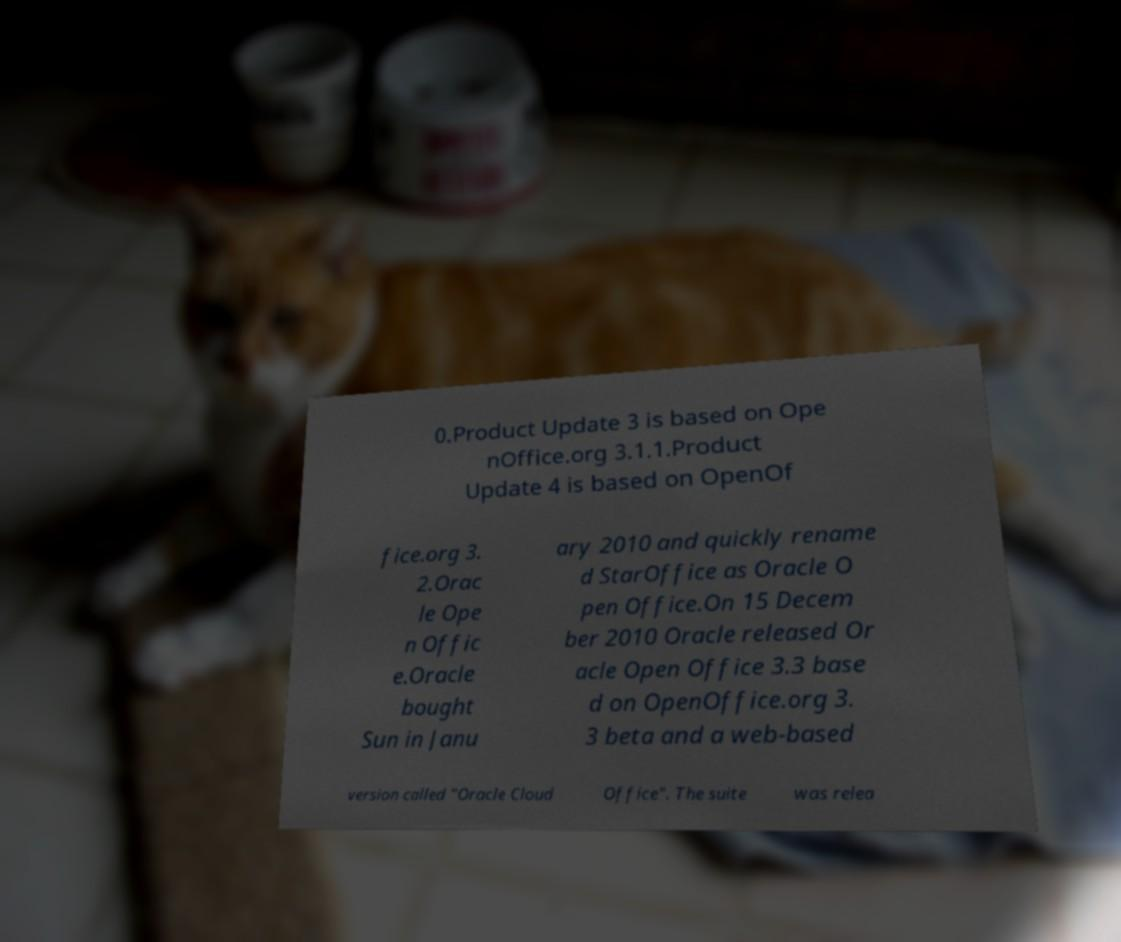I need the written content from this picture converted into text. Can you do that? 0.Product Update 3 is based on Ope nOffice.org 3.1.1.Product Update 4 is based on OpenOf fice.org 3. 2.Orac le Ope n Offic e.Oracle bought Sun in Janu ary 2010 and quickly rename d StarOffice as Oracle O pen Office.On 15 Decem ber 2010 Oracle released Or acle Open Office 3.3 base d on OpenOffice.org 3. 3 beta and a web-based version called "Oracle Cloud Office". The suite was relea 